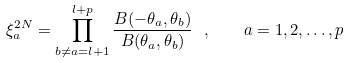Convert formula to latex. <formula><loc_0><loc_0><loc_500><loc_500>\xi _ { a } ^ { 2 N } = \prod _ { b \neq a = l + 1 } ^ { l + p } \frac { B ( - \theta _ { a } , \theta _ { b } ) } { B ( \theta _ { a } , \theta _ { b } ) } \ , \quad a = 1 , 2 , \dots , p</formula> 